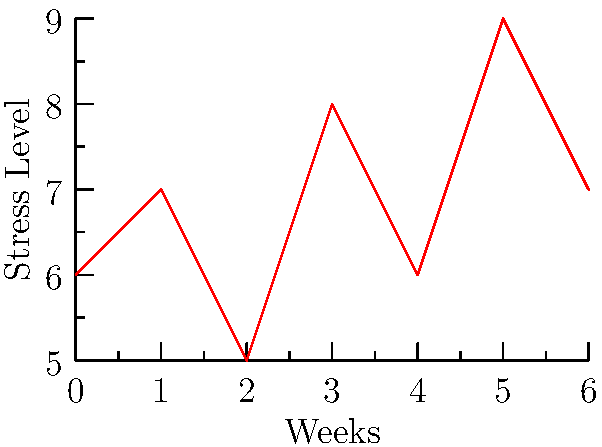As a therapist working with scrub nurses, you're tracking the average stress levels of a group over time. The graph shows the weekly average stress levels for the past 7 weeks, measured on a scale from 0 to 10. Calculate the overall average stress level for the entire period. To calculate the overall average stress level:

1. Sum up all the stress levels:
   $6 + 7 + 5 + 8 + 6 + 9 + 7 = 48$

2. Count the total number of data points:
   There are 7 weeks of data

3. Calculate the average by dividing the sum by the number of data points:
   $\frac{48}{7} = 6.857142857...$

4. Round to two decimal places:
   $6.86$
Answer: $6.86$ 